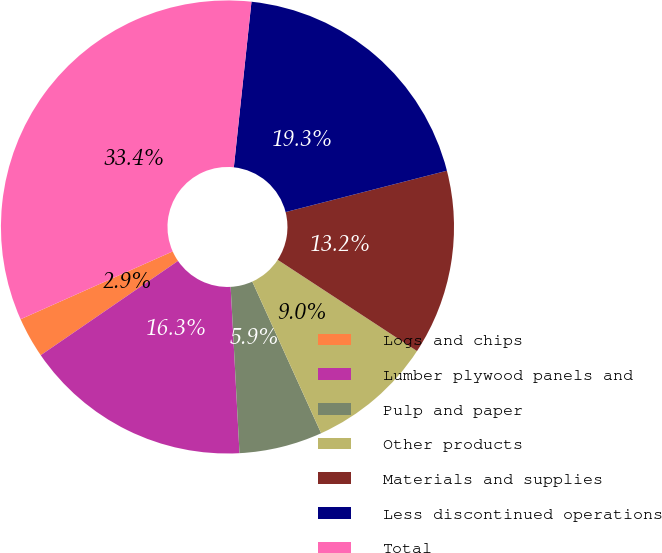Convert chart to OTSL. <chart><loc_0><loc_0><loc_500><loc_500><pie_chart><fcel>Logs and chips<fcel>Lumber plywood panels and<fcel>Pulp and paper<fcel>Other products<fcel>Materials and supplies<fcel>Less discontinued operations<fcel>Total<nl><fcel>2.9%<fcel>16.27%<fcel>5.94%<fcel>8.99%<fcel>13.22%<fcel>19.32%<fcel>33.37%<nl></chart> 